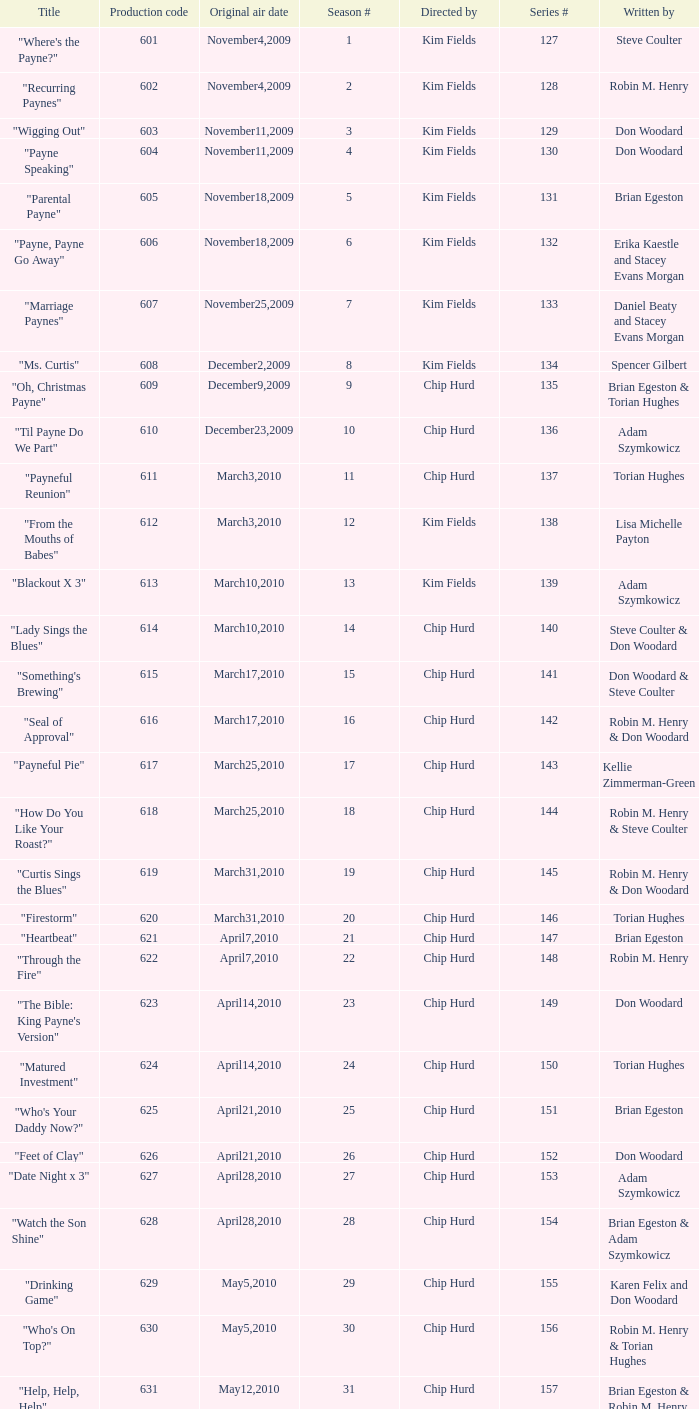Help me parse the entirety of this table. {'header': ['Title', 'Production code', 'Original air date', 'Season #', 'Directed by', 'Series #', 'Written by'], 'rows': [['"Where\'s the Payne?"', '601', 'November4,2009', '1', 'Kim Fields', '127', 'Steve Coulter'], ['"Recurring Paynes"', '602', 'November4,2009', '2', 'Kim Fields', '128', 'Robin M. Henry'], ['"Wigging Out"', '603', 'November11,2009', '3', 'Kim Fields', '129', 'Don Woodard'], ['"Payne Speaking"', '604', 'November11,2009', '4', 'Kim Fields', '130', 'Don Woodard'], ['"Parental Payne"', '605', 'November18,2009', '5', 'Kim Fields', '131', 'Brian Egeston'], ['"Payne, Payne Go Away"', '606', 'November18,2009', '6', 'Kim Fields', '132', 'Erika Kaestle and Stacey Evans Morgan'], ['"Marriage Paynes"', '607', 'November25,2009', '7', 'Kim Fields', '133', 'Daniel Beaty and Stacey Evans Morgan'], ['"Ms. Curtis"', '608', 'December2,2009', '8', 'Kim Fields', '134', 'Spencer Gilbert'], ['"Oh, Christmas Payne"', '609', 'December9,2009', '9', 'Chip Hurd', '135', 'Brian Egeston & Torian Hughes'], ['"Til Payne Do We Part"', '610', 'December23,2009', '10', 'Chip Hurd', '136', 'Adam Szymkowicz'], ['"Payneful Reunion"', '611', 'March3,2010', '11', 'Chip Hurd', '137', 'Torian Hughes'], ['"From the Mouths of Babes"', '612', 'March3,2010', '12', 'Kim Fields', '138', 'Lisa Michelle Payton'], ['"Blackout X 3"', '613', 'March10,2010', '13', 'Kim Fields', '139', 'Adam Szymkowicz'], ['"Lady Sings the Blues"', '614', 'March10,2010', '14', 'Chip Hurd', '140', 'Steve Coulter & Don Woodard'], ['"Something\'s Brewing"', '615', 'March17,2010', '15', 'Chip Hurd', '141', 'Don Woodard & Steve Coulter'], ['"Seal of Approval"', '616', 'March17,2010', '16', 'Chip Hurd', '142', 'Robin M. Henry & Don Woodard'], ['"Payneful Pie"', '617', 'March25,2010', '17', 'Chip Hurd', '143', 'Kellie Zimmerman-Green'], ['"How Do You Like Your Roast?"', '618', 'March25,2010', '18', 'Chip Hurd', '144', 'Robin M. Henry & Steve Coulter'], ['"Curtis Sings the Blues"', '619', 'March31,2010', '19', 'Chip Hurd', '145', 'Robin M. Henry & Don Woodard'], ['"Firestorm"', '620', 'March31,2010', '20', 'Chip Hurd', '146', 'Torian Hughes'], ['"Heartbeat"', '621', 'April7,2010', '21', 'Chip Hurd', '147', 'Brian Egeston'], ['"Through the Fire"', '622', 'April7,2010', '22', 'Chip Hurd', '148', 'Robin M. Henry'], ['"The Bible: King Payne\'s Version"', '623', 'April14,2010', '23', 'Chip Hurd', '149', 'Don Woodard'], ['"Matured Investment"', '624', 'April14,2010', '24', 'Chip Hurd', '150', 'Torian Hughes'], ['"Who\'s Your Daddy Now?"', '625', 'April21,2010', '25', 'Chip Hurd', '151', 'Brian Egeston'], ['"Feet of Clay"', '626', 'April21,2010', '26', 'Chip Hurd', '152', 'Don Woodard'], ['"Date Night x 3"', '627', 'April28,2010', '27', 'Chip Hurd', '153', 'Adam Szymkowicz'], ['"Watch the Son Shine"', '628', 'April28,2010', '28', 'Chip Hurd', '154', 'Brian Egeston & Adam Szymkowicz'], ['"Drinking Game"', '629', 'May5,2010', '29', 'Chip Hurd', '155', 'Karen Felix and Don Woodard'], ['"Who\'s On Top?"', '630', 'May5,2010', '30', 'Chip Hurd', '156', 'Robin M. Henry & Torian Hughes'], ['"Help, Help, Help"', '631', 'May12,2010', '31', 'Chip Hurd', '157', 'Brian Egeston & Robin M. Henry'], ['"Stinging Payne"', '632', 'May12,2010', '32', 'Chip Hurd', '158', 'Don Woodard'], ['"Worth Fighting For"', '633', 'May19,2010', '33', 'Chip Hurd', '159', 'Torian Hughes'], ['"Who\'s Your Nanny?"', '634', 'May19,2010', '34', 'Chip Hurd', '160', 'Robin M. Henry & Adam Szymkowicz'], ['"The Chef"', '635', 'May26,2010', '35', 'Chip Hurd', '161', 'Anthony C. Hill'], ['"My Fair Curtis"', '636', 'May26,2010', '36', 'Chip Hurd', '162', 'Don Woodard'], ['"Rest for the Weary"', '637', 'June2,2010', '37', 'Chip Hurd', '163', 'Brian Egeston'], ['"Thug Life"', '638', 'June2,2010', '38', 'Chip Hurd', '164', 'Torian Hughes'], ['"Rehabilitation"', '639', 'June9,2010', '39', 'Chip Hurd', '165', 'Adam Szymkowicz'], ['"A Payne In Need Is A Pain Indeed"', '640', 'June9,2010', '40', 'Chip Hurd', '166', 'Don Woodard'], ['"House Guest"', '641', 'January5,2011', '41', 'Chip Hurd', '167', 'David A. Arnold'], ['"Payne Showers"', '642', 'January5,2011', '42', 'Chip Hurd', '168', 'Omega Mariaunnie Stewart and Torian Hughes'], ['"Playing With Fire"', '643', 'January12,2011', '43', 'Chip Hurd', '169', 'Carlos Portugal'], ['"When the Payne\'s Away"', '644', 'January12,2011', '44', 'Chip Hurd', '170', 'Kristin Topps and Don Woodard'], ['"Beginnings"', '645', 'January19,2011', '45', 'Chip Hurd', '171', 'Myra J.']]} What is the original air dates for the title "firestorm"? March31,2010. 